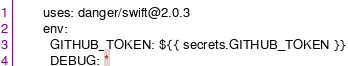<code> <loc_0><loc_0><loc_500><loc_500><_YAML_>        uses: danger/swift@2.0.3
        env:
          GITHUB_TOKEN: ${{ secrets.GITHUB_TOKEN }}
          DEBUG: *
</code> 